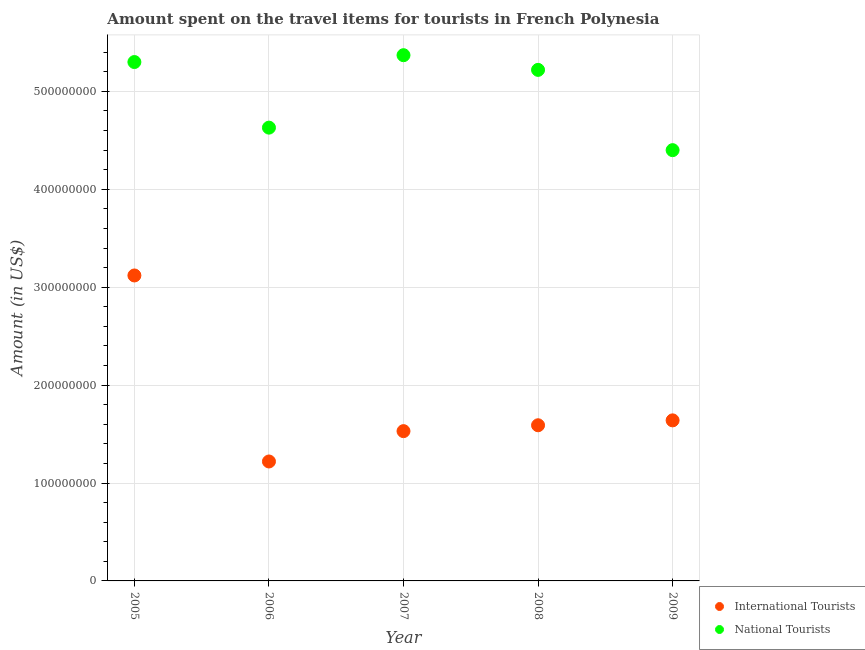Is the number of dotlines equal to the number of legend labels?
Give a very brief answer. Yes. What is the amount spent on travel items of international tourists in 2009?
Offer a terse response. 1.64e+08. Across all years, what is the maximum amount spent on travel items of international tourists?
Your answer should be very brief. 3.12e+08. Across all years, what is the minimum amount spent on travel items of international tourists?
Keep it short and to the point. 1.22e+08. In which year was the amount spent on travel items of international tourists maximum?
Make the answer very short. 2005. In which year was the amount spent on travel items of national tourists minimum?
Make the answer very short. 2009. What is the total amount spent on travel items of national tourists in the graph?
Give a very brief answer. 2.49e+09. What is the difference between the amount spent on travel items of international tourists in 2005 and that in 2009?
Give a very brief answer. 1.48e+08. What is the difference between the amount spent on travel items of international tourists in 2006 and the amount spent on travel items of national tourists in 2009?
Give a very brief answer. -3.18e+08. What is the average amount spent on travel items of international tourists per year?
Your response must be concise. 1.82e+08. In the year 2005, what is the difference between the amount spent on travel items of international tourists and amount spent on travel items of national tourists?
Your answer should be compact. -2.18e+08. What is the ratio of the amount spent on travel items of international tourists in 2006 to that in 2007?
Your answer should be very brief. 0.8. Is the difference between the amount spent on travel items of national tourists in 2007 and 2009 greater than the difference between the amount spent on travel items of international tourists in 2007 and 2009?
Make the answer very short. Yes. What is the difference between the highest and the second highest amount spent on travel items of international tourists?
Your answer should be very brief. 1.48e+08. What is the difference between the highest and the lowest amount spent on travel items of national tourists?
Keep it short and to the point. 9.70e+07. In how many years, is the amount spent on travel items of international tourists greater than the average amount spent on travel items of international tourists taken over all years?
Provide a succinct answer. 1. Is the sum of the amount spent on travel items of national tourists in 2007 and 2009 greater than the maximum amount spent on travel items of international tourists across all years?
Your response must be concise. Yes. Is the amount spent on travel items of national tourists strictly greater than the amount spent on travel items of international tourists over the years?
Offer a very short reply. Yes. How many dotlines are there?
Your response must be concise. 2. How many years are there in the graph?
Keep it short and to the point. 5. What is the difference between two consecutive major ticks on the Y-axis?
Offer a very short reply. 1.00e+08. Are the values on the major ticks of Y-axis written in scientific E-notation?
Provide a succinct answer. No. Does the graph contain any zero values?
Your answer should be very brief. No. Does the graph contain grids?
Ensure brevity in your answer.  Yes. Where does the legend appear in the graph?
Keep it short and to the point. Bottom right. What is the title of the graph?
Make the answer very short. Amount spent on the travel items for tourists in French Polynesia. What is the Amount (in US$) of International Tourists in 2005?
Offer a terse response. 3.12e+08. What is the Amount (in US$) in National Tourists in 2005?
Your response must be concise. 5.30e+08. What is the Amount (in US$) in International Tourists in 2006?
Keep it short and to the point. 1.22e+08. What is the Amount (in US$) of National Tourists in 2006?
Ensure brevity in your answer.  4.63e+08. What is the Amount (in US$) of International Tourists in 2007?
Ensure brevity in your answer.  1.53e+08. What is the Amount (in US$) of National Tourists in 2007?
Make the answer very short. 5.37e+08. What is the Amount (in US$) in International Tourists in 2008?
Provide a short and direct response. 1.59e+08. What is the Amount (in US$) of National Tourists in 2008?
Your answer should be compact. 5.22e+08. What is the Amount (in US$) of International Tourists in 2009?
Your response must be concise. 1.64e+08. What is the Amount (in US$) of National Tourists in 2009?
Give a very brief answer. 4.40e+08. Across all years, what is the maximum Amount (in US$) in International Tourists?
Make the answer very short. 3.12e+08. Across all years, what is the maximum Amount (in US$) in National Tourists?
Give a very brief answer. 5.37e+08. Across all years, what is the minimum Amount (in US$) of International Tourists?
Provide a succinct answer. 1.22e+08. Across all years, what is the minimum Amount (in US$) in National Tourists?
Keep it short and to the point. 4.40e+08. What is the total Amount (in US$) in International Tourists in the graph?
Your response must be concise. 9.10e+08. What is the total Amount (in US$) in National Tourists in the graph?
Keep it short and to the point. 2.49e+09. What is the difference between the Amount (in US$) of International Tourists in 2005 and that in 2006?
Make the answer very short. 1.90e+08. What is the difference between the Amount (in US$) of National Tourists in 2005 and that in 2006?
Make the answer very short. 6.70e+07. What is the difference between the Amount (in US$) in International Tourists in 2005 and that in 2007?
Offer a very short reply. 1.59e+08. What is the difference between the Amount (in US$) in National Tourists in 2005 and that in 2007?
Make the answer very short. -7.00e+06. What is the difference between the Amount (in US$) in International Tourists in 2005 and that in 2008?
Provide a short and direct response. 1.53e+08. What is the difference between the Amount (in US$) in National Tourists in 2005 and that in 2008?
Offer a terse response. 8.00e+06. What is the difference between the Amount (in US$) in International Tourists in 2005 and that in 2009?
Give a very brief answer. 1.48e+08. What is the difference between the Amount (in US$) of National Tourists in 2005 and that in 2009?
Provide a succinct answer. 9.00e+07. What is the difference between the Amount (in US$) of International Tourists in 2006 and that in 2007?
Your answer should be very brief. -3.10e+07. What is the difference between the Amount (in US$) in National Tourists in 2006 and that in 2007?
Offer a very short reply. -7.40e+07. What is the difference between the Amount (in US$) of International Tourists in 2006 and that in 2008?
Keep it short and to the point. -3.70e+07. What is the difference between the Amount (in US$) of National Tourists in 2006 and that in 2008?
Give a very brief answer. -5.90e+07. What is the difference between the Amount (in US$) of International Tourists in 2006 and that in 2009?
Keep it short and to the point. -4.20e+07. What is the difference between the Amount (in US$) of National Tourists in 2006 and that in 2009?
Offer a very short reply. 2.30e+07. What is the difference between the Amount (in US$) of International Tourists in 2007 and that in 2008?
Your answer should be compact. -6.00e+06. What is the difference between the Amount (in US$) in National Tourists in 2007 and that in 2008?
Provide a succinct answer. 1.50e+07. What is the difference between the Amount (in US$) of International Tourists in 2007 and that in 2009?
Your answer should be very brief. -1.10e+07. What is the difference between the Amount (in US$) in National Tourists in 2007 and that in 2009?
Keep it short and to the point. 9.70e+07. What is the difference between the Amount (in US$) in International Tourists in 2008 and that in 2009?
Provide a succinct answer. -5.00e+06. What is the difference between the Amount (in US$) of National Tourists in 2008 and that in 2009?
Your answer should be very brief. 8.20e+07. What is the difference between the Amount (in US$) in International Tourists in 2005 and the Amount (in US$) in National Tourists in 2006?
Offer a terse response. -1.51e+08. What is the difference between the Amount (in US$) in International Tourists in 2005 and the Amount (in US$) in National Tourists in 2007?
Make the answer very short. -2.25e+08. What is the difference between the Amount (in US$) of International Tourists in 2005 and the Amount (in US$) of National Tourists in 2008?
Keep it short and to the point. -2.10e+08. What is the difference between the Amount (in US$) in International Tourists in 2005 and the Amount (in US$) in National Tourists in 2009?
Provide a succinct answer. -1.28e+08. What is the difference between the Amount (in US$) of International Tourists in 2006 and the Amount (in US$) of National Tourists in 2007?
Ensure brevity in your answer.  -4.15e+08. What is the difference between the Amount (in US$) in International Tourists in 2006 and the Amount (in US$) in National Tourists in 2008?
Your response must be concise. -4.00e+08. What is the difference between the Amount (in US$) in International Tourists in 2006 and the Amount (in US$) in National Tourists in 2009?
Your answer should be very brief. -3.18e+08. What is the difference between the Amount (in US$) of International Tourists in 2007 and the Amount (in US$) of National Tourists in 2008?
Give a very brief answer. -3.69e+08. What is the difference between the Amount (in US$) in International Tourists in 2007 and the Amount (in US$) in National Tourists in 2009?
Your answer should be very brief. -2.87e+08. What is the difference between the Amount (in US$) in International Tourists in 2008 and the Amount (in US$) in National Tourists in 2009?
Offer a very short reply. -2.81e+08. What is the average Amount (in US$) in International Tourists per year?
Ensure brevity in your answer.  1.82e+08. What is the average Amount (in US$) in National Tourists per year?
Provide a succinct answer. 4.98e+08. In the year 2005, what is the difference between the Amount (in US$) of International Tourists and Amount (in US$) of National Tourists?
Offer a very short reply. -2.18e+08. In the year 2006, what is the difference between the Amount (in US$) in International Tourists and Amount (in US$) in National Tourists?
Your response must be concise. -3.41e+08. In the year 2007, what is the difference between the Amount (in US$) of International Tourists and Amount (in US$) of National Tourists?
Your answer should be very brief. -3.84e+08. In the year 2008, what is the difference between the Amount (in US$) in International Tourists and Amount (in US$) in National Tourists?
Your answer should be compact. -3.63e+08. In the year 2009, what is the difference between the Amount (in US$) of International Tourists and Amount (in US$) of National Tourists?
Your response must be concise. -2.76e+08. What is the ratio of the Amount (in US$) of International Tourists in 2005 to that in 2006?
Your answer should be very brief. 2.56. What is the ratio of the Amount (in US$) of National Tourists in 2005 to that in 2006?
Ensure brevity in your answer.  1.14. What is the ratio of the Amount (in US$) in International Tourists in 2005 to that in 2007?
Offer a very short reply. 2.04. What is the ratio of the Amount (in US$) in International Tourists in 2005 to that in 2008?
Keep it short and to the point. 1.96. What is the ratio of the Amount (in US$) in National Tourists in 2005 to that in 2008?
Provide a succinct answer. 1.02. What is the ratio of the Amount (in US$) in International Tourists in 2005 to that in 2009?
Offer a terse response. 1.9. What is the ratio of the Amount (in US$) of National Tourists in 2005 to that in 2009?
Your response must be concise. 1.2. What is the ratio of the Amount (in US$) in International Tourists in 2006 to that in 2007?
Offer a terse response. 0.8. What is the ratio of the Amount (in US$) in National Tourists in 2006 to that in 2007?
Keep it short and to the point. 0.86. What is the ratio of the Amount (in US$) in International Tourists in 2006 to that in 2008?
Provide a succinct answer. 0.77. What is the ratio of the Amount (in US$) of National Tourists in 2006 to that in 2008?
Provide a short and direct response. 0.89. What is the ratio of the Amount (in US$) in International Tourists in 2006 to that in 2009?
Offer a very short reply. 0.74. What is the ratio of the Amount (in US$) of National Tourists in 2006 to that in 2009?
Your answer should be very brief. 1.05. What is the ratio of the Amount (in US$) in International Tourists in 2007 to that in 2008?
Offer a very short reply. 0.96. What is the ratio of the Amount (in US$) of National Tourists in 2007 to that in 2008?
Provide a short and direct response. 1.03. What is the ratio of the Amount (in US$) in International Tourists in 2007 to that in 2009?
Offer a very short reply. 0.93. What is the ratio of the Amount (in US$) in National Tourists in 2007 to that in 2009?
Keep it short and to the point. 1.22. What is the ratio of the Amount (in US$) of International Tourists in 2008 to that in 2009?
Provide a succinct answer. 0.97. What is the ratio of the Amount (in US$) in National Tourists in 2008 to that in 2009?
Keep it short and to the point. 1.19. What is the difference between the highest and the second highest Amount (in US$) in International Tourists?
Give a very brief answer. 1.48e+08. What is the difference between the highest and the second highest Amount (in US$) of National Tourists?
Ensure brevity in your answer.  7.00e+06. What is the difference between the highest and the lowest Amount (in US$) in International Tourists?
Your response must be concise. 1.90e+08. What is the difference between the highest and the lowest Amount (in US$) in National Tourists?
Provide a succinct answer. 9.70e+07. 